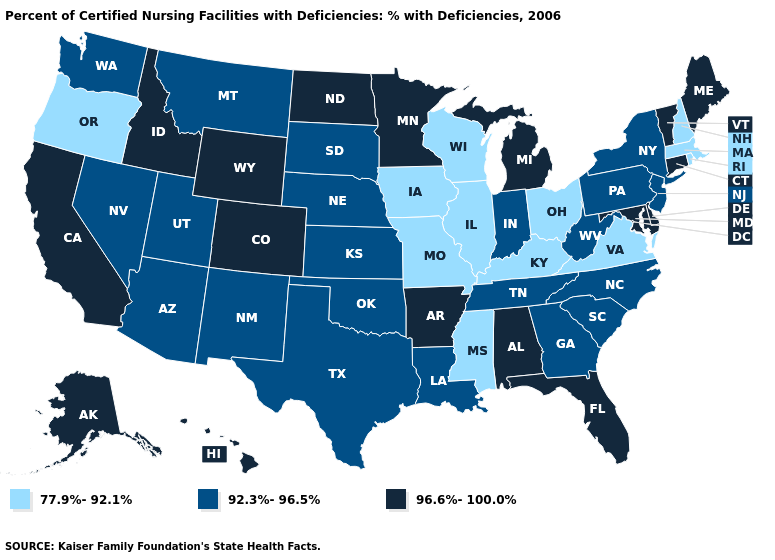Which states have the highest value in the USA?
Concise answer only. Alabama, Alaska, Arkansas, California, Colorado, Connecticut, Delaware, Florida, Hawaii, Idaho, Maine, Maryland, Michigan, Minnesota, North Dakota, Vermont, Wyoming. What is the value of Wisconsin?
Give a very brief answer. 77.9%-92.1%. Does South Carolina have a lower value than New Hampshire?
Keep it brief. No. Does Alabama have the same value as Oklahoma?
Keep it brief. No. Among the states that border New Jersey , does New York have the highest value?
Keep it brief. No. What is the value of Oregon?
Write a very short answer. 77.9%-92.1%. What is the value of Delaware?
Answer briefly. 96.6%-100.0%. Which states have the highest value in the USA?
Answer briefly. Alabama, Alaska, Arkansas, California, Colorado, Connecticut, Delaware, Florida, Hawaii, Idaho, Maine, Maryland, Michigan, Minnesota, North Dakota, Vermont, Wyoming. What is the value of Vermont?
Concise answer only. 96.6%-100.0%. What is the value of Nebraska?
Answer briefly. 92.3%-96.5%. Does New Hampshire have the highest value in the Northeast?
Short answer required. No. Does Ohio have the lowest value in the USA?
Concise answer only. Yes. What is the lowest value in states that border Vermont?
Write a very short answer. 77.9%-92.1%. Among the states that border New Jersey , does Pennsylvania have the highest value?
Give a very brief answer. No. What is the value of New Hampshire?
Short answer required. 77.9%-92.1%. 